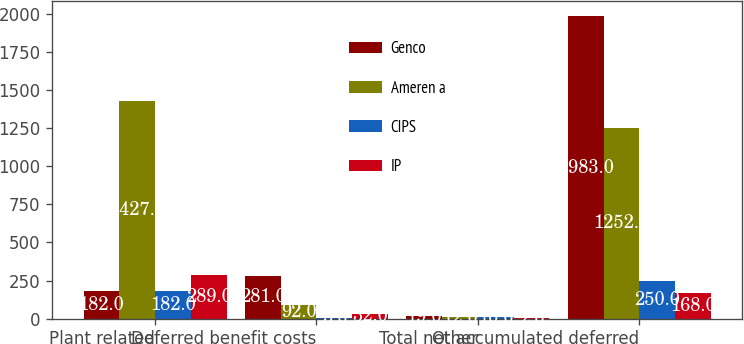Convert chart. <chart><loc_0><loc_0><loc_500><loc_500><stacked_bar_chart><ecel><fcel>Plant related<fcel>Deferred benefit costs<fcel>Other<fcel>Total net accumulated deferred<nl><fcel>Genco<fcel>182<fcel>281<fcel>19<fcel>1983<nl><fcel>Ameren a<fcel>1427<fcel>92<fcel>12<fcel>1252<nl><fcel>CIPS<fcel>182<fcel>5<fcel>10<fcel>250<nl><fcel>IP<fcel>289<fcel>32<fcel>2<fcel>168<nl></chart> 